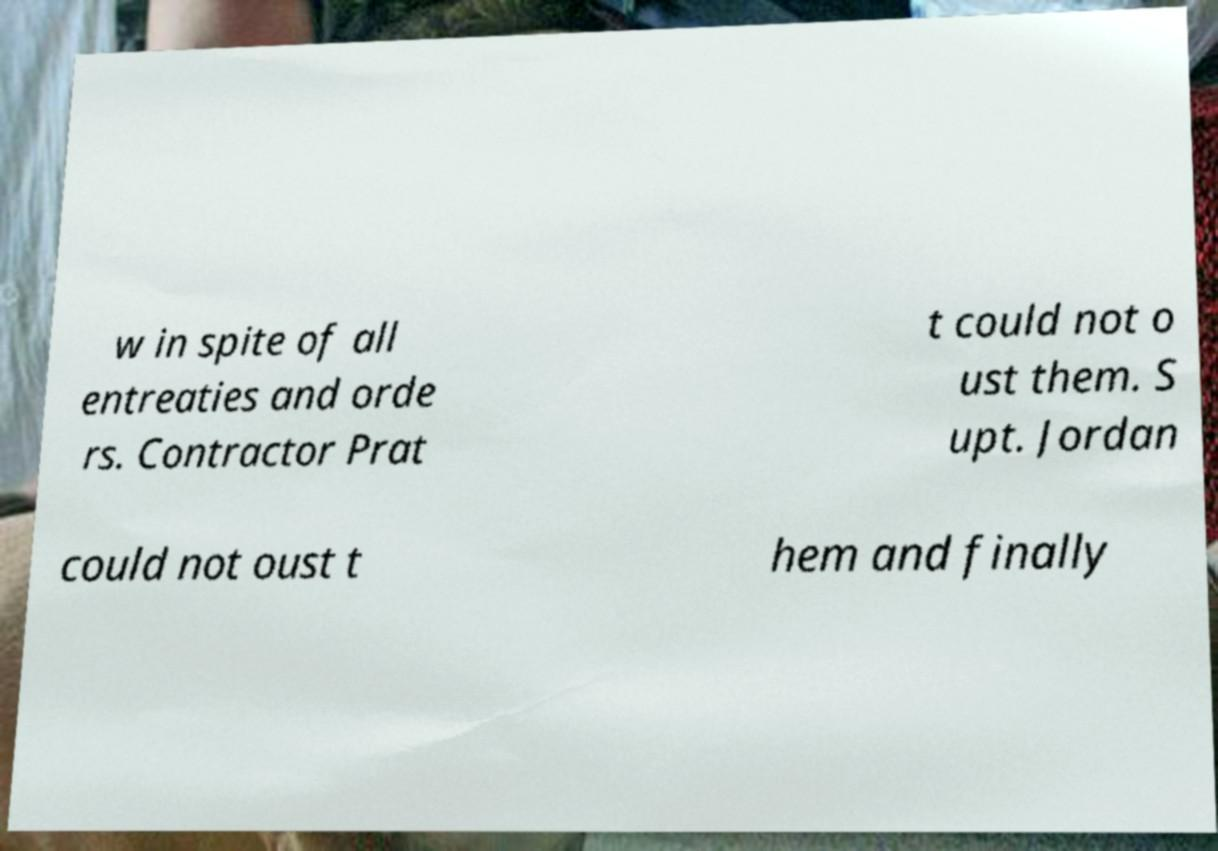Please identify and transcribe the text found in this image. w in spite of all entreaties and orde rs. Contractor Prat t could not o ust them. S upt. Jordan could not oust t hem and finally 